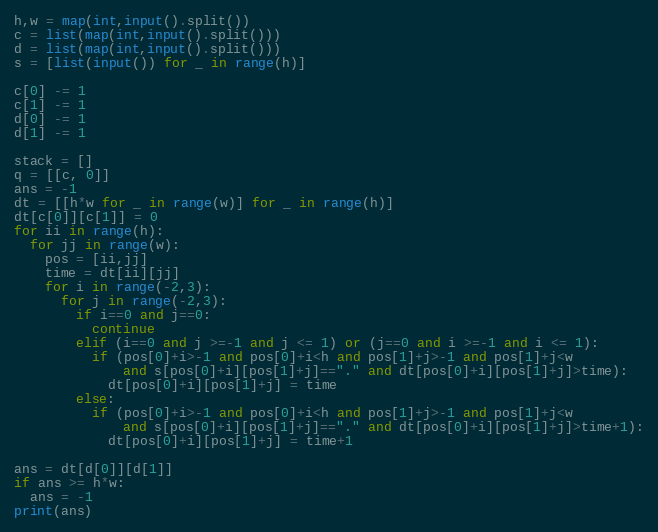Convert code to text. <code><loc_0><loc_0><loc_500><loc_500><_Python_>h,w = map(int,input().split())
c = list(map(int,input().split()))
d = list(map(int,input().split()))
s = [list(input()) for _ in range(h)]

c[0] -= 1
c[1] -= 1
d[0] -= 1
d[1] -= 1

stack = []
q = [[c, 0]]
ans = -1
dt = [[h*w for _ in range(w)] for _ in range(h)]
dt[c[0]][c[1]] = 0
for ii in range(h):
  for jj in range(w):
    pos = [ii,jj]
    time = dt[ii][jj]
    for i in range(-2,3):
      for j in range(-2,3):
        if i==0 and j==0:
          continue
        elif (i==0 and j >=-1 and j <= 1) or (j==0 and i >=-1 and i <= 1):
          if (pos[0]+i>-1 and pos[0]+i<h and pos[1]+j>-1 and pos[1]+j<w
              and s[pos[0]+i][pos[1]+j]=="." and dt[pos[0]+i][pos[1]+j]>time):
            dt[pos[0]+i][pos[1]+j] = time
        else:
          if (pos[0]+i>-1 and pos[0]+i<h and pos[1]+j>-1 and pos[1]+j<w
              and s[pos[0]+i][pos[1]+j]=="." and dt[pos[0]+i][pos[1]+j]>time+1):
            dt[pos[0]+i][pos[1]+j] = time+1

ans = dt[d[0]][d[1]]
if ans >= h*w:
  ans = -1
print(ans)</code> 